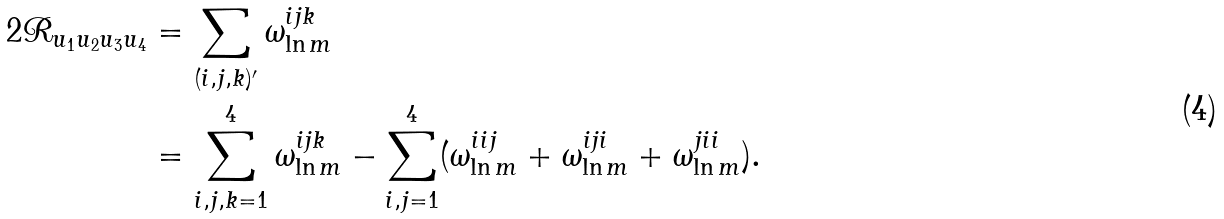Convert formula to latex. <formula><loc_0><loc_0><loc_500><loc_500>2 \mathcal { R } _ { u _ { 1 } u _ { 2 } u _ { 3 } u _ { 4 } } & = \sum _ { ( i , j , k ) ^ { \prime } } \omega ^ { i j k } _ { \ln m } \\ & = \sum _ { i , j , k = 1 } ^ { 4 } \omega ^ { i j k } _ { \ln m } - \sum _ { i , j = 1 } ^ { 4 } ( \omega ^ { i i j } _ { \ln m } + \omega ^ { i j i } _ { \ln m } + \omega ^ { j i i } _ { \ln m } ) .</formula> 